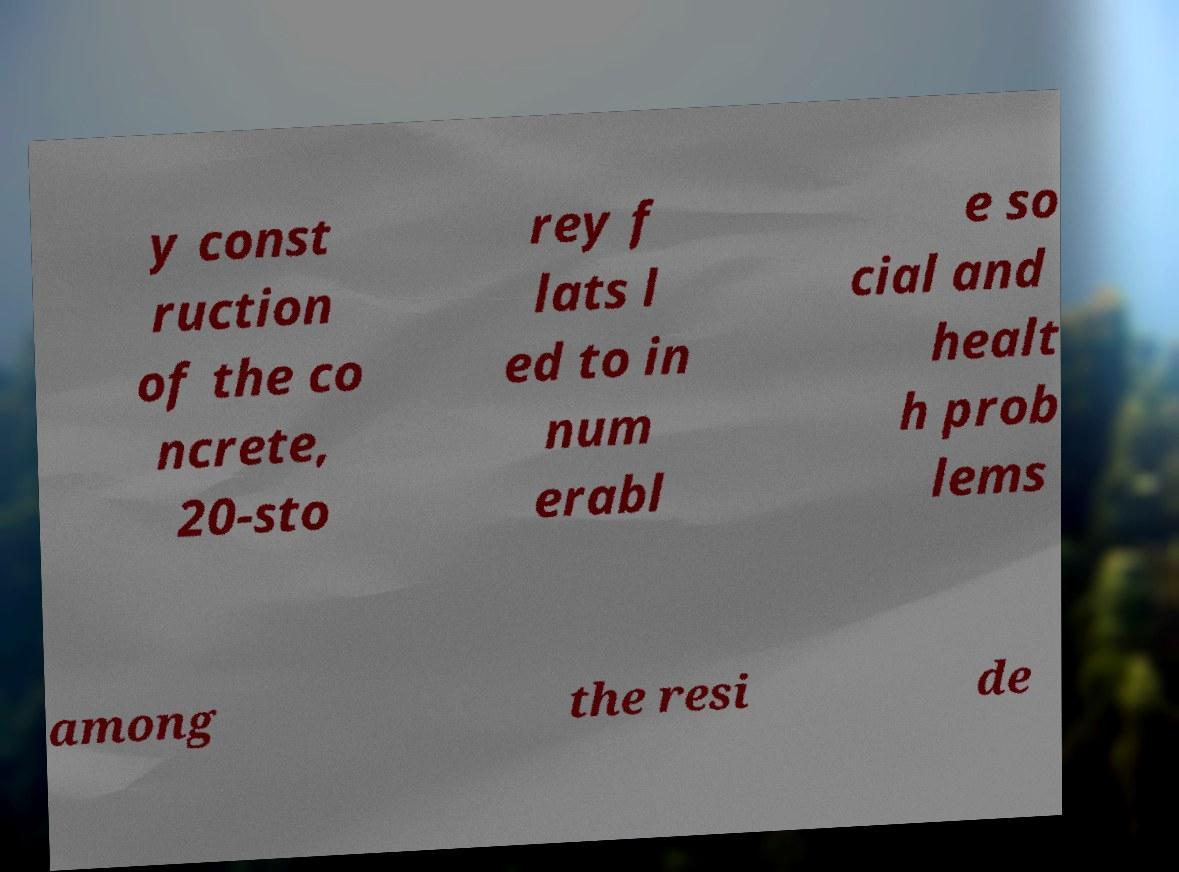Please read and relay the text visible in this image. What does it say? y const ruction of the co ncrete, 20-sto rey f lats l ed to in num erabl e so cial and healt h prob lems among the resi de 